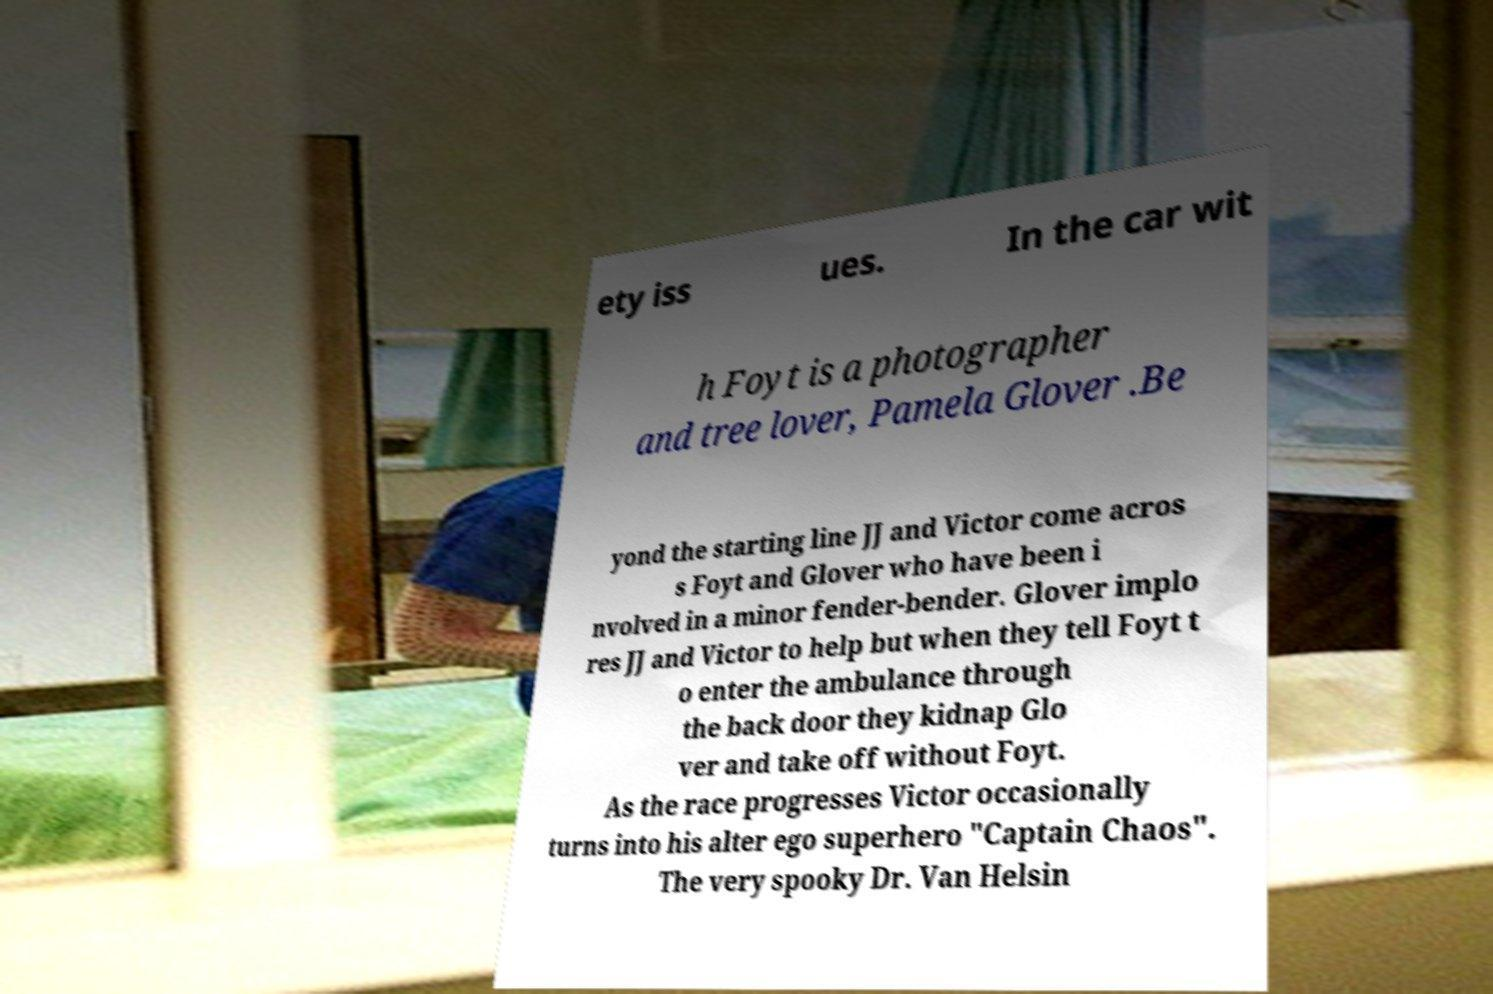Could you assist in decoding the text presented in this image and type it out clearly? ety iss ues. In the car wit h Foyt is a photographer and tree lover, Pamela Glover .Be yond the starting line JJ and Victor come acros s Foyt and Glover who have been i nvolved in a minor fender-bender. Glover implo res JJ and Victor to help but when they tell Foyt t o enter the ambulance through the back door they kidnap Glo ver and take off without Foyt. As the race progresses Victor occasionally turns into his alter ego superhero "Captain Chaos". The very spooky Dr. Van Helsin 